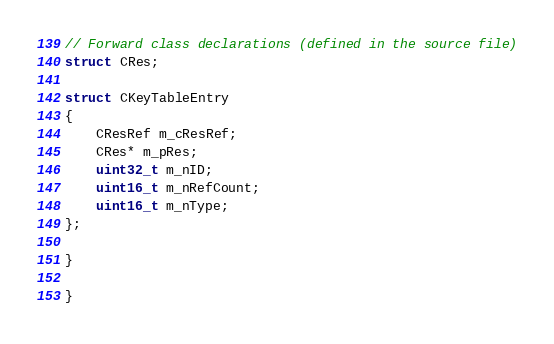<code> <loc_0><loc_0><loc_500><loc_500><_C++_>
// Forward class declarations (defined in the source file)
struct CRes;

struct CKeyTableEntry
{
    CResRef m_cResRef;
    CRes* m_pRes;
    uint32_t m_nID;
    uint16_t m_nRefCount;
    uint16_t m_nType;
};

}

}
</code> 